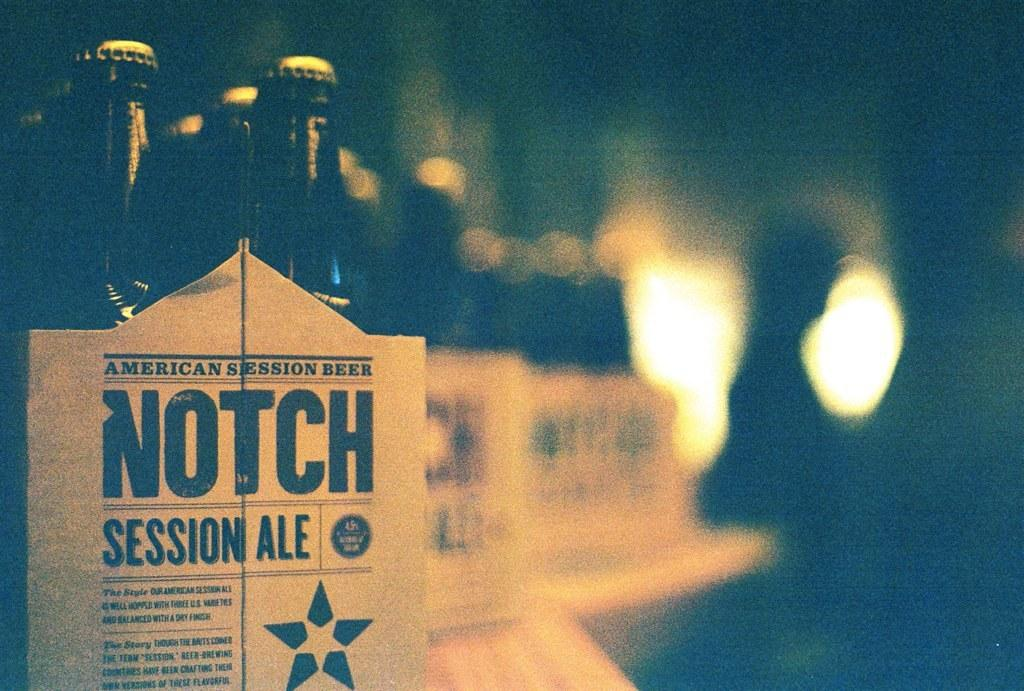<image>
Create a compact narrative representing the image presented. a six pack of notch session ale in a dark photo 